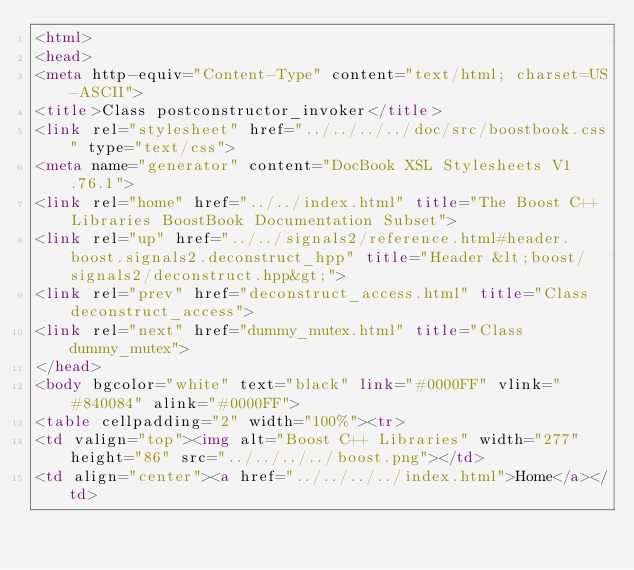Convert code to text. <code><loc_0><loc_0><loc_500><loc_500><_HTML_><html>
<head>
<meta http-equiv="Content-Type" content="text/html; charset=US-ASCII">
<title>Class postconstructor_invoker</title>
<link rel="stylesheet" href="../../../../doc/src/boostbook.css" type="text/css">
<meta name="generator" content="DocBook XSL Stylesheets V1.76.1">
<link rel="home" href="../../index.html" title="The Boost C++ Libraries BoostBook Documentation Subset">
<link rel="up" href="../../signals2/reference.html#header.boost.signals2.deconstruct_hpp" title="Header &lt;boost/signals2/deconstruct.hpp&gt;">
<link rel="prev" href="deconstruct_access.html" title="Class deconstruct_access">
<link rel="next" href="dummy_mutex.html" title="Class dummy_mutex">
</head>
<body bgcolor="white" text="black" link="#0000FF" vlink="#840084" alink="#0000FF">
<table cellpadding="2" width="100%"><tr>
<td valign="top"><img alt="Boost C++ Libraries" width="277" height="86" src="../../../../boost.png"></td>
<td align="center"><a href="../../../../index.html">Home</a></td></code> 